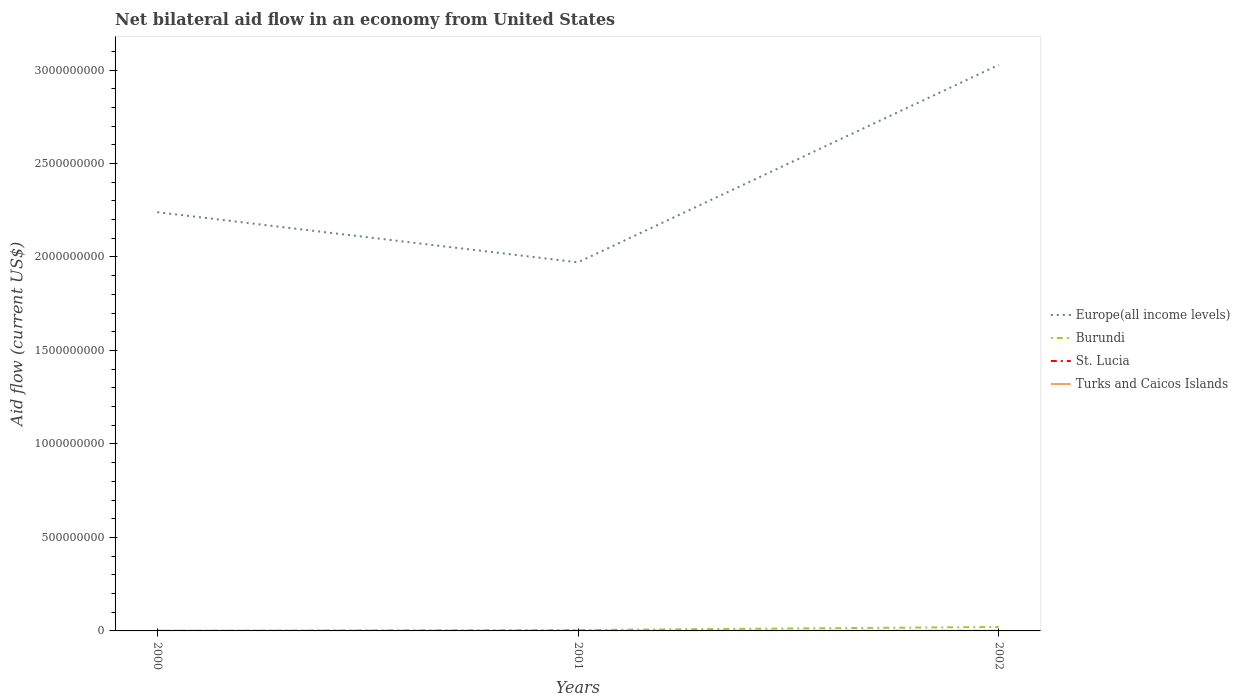Is the number of lines equal to the number of legend labels?
Provide a short and direct response. Yes. Across all years, what is the maximum net bilateral aid flow in Burundi?
Your answer should be very brief. 9.60e+05. In which year was the net bilateral aid flow in St. Lucia maximum?
Ensure brevity in your answer.  2001. What is the difference between the highest and the second highest net bilateral aid flow in Burundi?
Keep it short and to the point. 2.02e+07. Is the net bilateral aid flow in Turks and Caicos Islands strictly greater than the net bilateral aid flow in Burundi over the years?
Your response must be concise. Yes. How many lines are there?
Ensure brevity in your answer.  4. What is the difference between two consecutive major ticks on the Y-axis?
Provide a short and direct response. 5.00e+08. Does the graph contain any zero values?
Ensure brevity in your answer.  No. Does the graph contain grids?
Ensure brevity in your answer.  No. Where does the legend appear in the graph?
Provide a succinct answer. Center right. How many legend labels are there?
Offer a terse response. 4. What is the title of the graph?
Make the answer very short. Net bilateral aid flow in an economy from United States. What is the Aid flow (current US$) of Europe(all income levels) in 2000?
Your answer should be compact. 2.24e+09. What is the Aid flow (current US$) in Burundi in 2000?
Offer a terse response. 9.60e+05. What is the Aid flow (current US$) in St. Lucia in 2000?
Your response must be concise. 2.90e+05. What is the Aid flow (current US$) in Turks and Caicos Islands in 2000?
Ensure brevity in your answer.  10000. What is the Aid flow (current US$) in Europe(all income levels) in 2001?
Give a very brief answer. 1.97e+09. What is the Aid flow (current US$) of Burundi in 2001?
Your answer should be very brief. 4.85e+06. What is the Aid flow (current US$) of Turks and Caicos Islands in 2001?
Provide a succinct answer. 4.00e+04. What is the Aid flow (current US$) of Europe(all income levels) in 2002?
Your answer should be compact. 3.03e+09. What is the Aid flow (current US$) in Burundi in 2002?
Offer a very short reply. 2.12e+07. What is the Aid flow (current US$) of St. Lucia in 2002?
Your answer should be compact. 2.40e+05. What is the Aid flow (current US$) of Turks and Caicos Islands in 2002?
Ensure brevity in your answer.  10000. Across all years, what is the maximum Aid flow (current US$) of Europe(all income levels)?
Provide a short and direct response. 3.03e+09. Across all years, what is the maximum Aid flow (current US$) of Burundi?
Make the answer very short. 2.12e+07. Across all years, what is the maximum Aid flow (current US$) of St. Lucia?
Your response must be concise. 2.90e+05. Across all years, what is the minimum Aid flow (current US$) in Europe(all income levels)?
Provide a succinct answer. 1.97e+09. Across all years, what is the minimum Aid flow (current US$) of Burundi?
Provide a short and direct response. 9.60e+05. Across all years, what is the minimum Aid flow (current US$) of St. Lucia?
Provide a succinct answer. 1.50e+05. What is the total Aid flow (current US$) in Europe(all income levels) in the graph?
Keep it short and to the point. 7.24e+09. What is the total Aid flow (current US$) of Burundi in the graph?
Ensure brevity in your answer.  2.70e+07. What is the total Aid flow (current US$) in St. Lucia in the graph?
Provide a succinct answer. 6.80e+05. What is the difference between the Aid flow (current US$) in Europe(all income levels) in 2000 and that in 2001?
Offer a very short reply. 2.68e+08. What is the difference between the Aid flow (current US$) of Burundi in 2000 and that in 2001?
Give a very brief answer. -3.89e+06. What is the difference between the Aid flow (current US$) in St. Lucia in 2000 and that in 2001?
Give a very brief answer. 1.40e+05. What is the difference between the Aid flow (current US$) of Turks and Caicos Islands in 2000 and that in 2001?
Keep it short and to the point. -3.00e+04. What is the difference between the Aid flow (current US$) of Europe(all income levels) in 2000 and that in 2002?
Ensure brevity in your answer.  -7.88e+08. What is the difference between the Aid flow (current US$) in Burundi in 2000 and that in 2002?
Offer a terse response. -2.02e+07. What is the difference between the Aid flow (current US$) in St. Lucia in 2000 and that in 2002?
Give a very brief answer. 5.00e+04. What is the difference between the Aid flow (current US$) of Europe(all income levels) in 2001 and that in 2002?
Your answer should be very brief. -1.06e+09. What is the difference between the Aid flow (current US$) in Burundi in 2001 and that in 2002?
Offer a terse response. -1.63e+07. What is the difference between the Aid flow (current US$) of Turks and Caicos Islands in 2001 and that in 2002?
Offer a very short reply. 3.00e+04. What is the difference between the Aid flow (current US$) of Europe(all income levels) in 2000 and the Aid flow (current US$) of Burundi in 2001?
Offer a terse response. 2.23e+09. What is the difference between the Aid flow (current US$) of Europe(all income levels) in 2000 and the Aid flow (current US$) of St. Lucia in 2001?
Your response must be concise. 2.24e+09. What is the difference between the Aid flow (current US$) of Europe(all income levels) in 2000 and the Aid flow (current US$) of Turks and Caicos Islands in 2001?
Offer a terse response. 2.24e+09. What is the difference between the Aid flow (current US$) in Burundi in 2000 and the Aid flow (current US$) in St. Lucia in 2001?
Ensure brevity in your answer.  8.10e+05. What is the difference between the Aid flow (current US$) of Burundi in 2000 and the Aid flow (current US$) of Turks and Caicos Islands in 2001?
Make the answer very short. 9.20e+05. What is the difference between the Aid flow (current US$) in St. Lucia in 2000 and the Aid flow (current US$) in Turks and Caicos Islands in 2001?
Give a very brief answer. 2.50e+05. What is the difference between the Aid flow (current US$) in Europe(all income levels) in 2000 and the Aid flow (current US$) in Burundi in 2002?
Provide a succinct answer. 2.22e+09. What is the difference between the Aid flow (current US$) in Europe(all income levels) in 2000 and the Aid flow (current US$) in St. Lucia in 2002?
Provide a succinct answer. 2.24e+09. What is the difference between the Aid flow (current US$) in Europe(all income levels) in 2000 and the Aid flow (current US$) in Turks and Caicos Islands in 2002?
Ensure brevity in your answer.  2.24e+09. What is the difference between the Aid flow (current US$) of Burundi in 2000 and the Aid flow (current US$) of St. Lucia in 2002?
Provide a succinct answer. 7.20e+05. What is the difference between the Aid flow (current US$) in Burundi in 2000 and the Aid flow (current US$) in Turks and Caicos Islands in 2002?
Give a very brief answer. 9.50e+05. What is the difference between the Aid flow (current US$) of Europe(all income levels) in 2001 and the Aid flow (current US$) of Burundi in 2002?
Offer a terse response. 1.95e+09. What is the difference between the Aid flow (current US$) of Europe(all income levels) in 2001 and the Aid flow (current US$) of St. Lucia in 2002?
Provide a succinct answer. 1.97e+09. What is the difference between the Aid flow (current US$) in Europe(all income levels) in 2001 and the Aid flow (current US$) in Turks and Caicos Islands in 2002?
Give a very brief answer. 1.97e+09. What is the difference between the Aid flow (current US$) of Burundi in 2001 and the Aid flow (current US$) of St. Lucia in 2002?
Keep it short and to the point. 4.61e+06. What is the difference between the Aid flow (current US$) in Burundi in 2001 and the Aid flow (current US$) in Turks and Caicos Islands in 2002?
Provide a succinct answer. 4.84e+06. What is the average Aid flow (current US$) in Europe(all income levels) per year?
Your response must be concise. 2.41e+09. What is the average Aid flow (current US$) in Burundi per year?
Your answer should be compact. 8.99e+06. What is the average Aid flow (current US$) of St. Lucia per year?
Your response must be concise. 2.27e+05. In the year 2000, what is the difference between the Aid flow (current US$) in Europe(all income levels) and Aid flow (current US$) in Burundi?
Ensure brevity in your answer.  2.24e+09. In the year 2000, what is the difference between the Aid flow (current US$) of Europe(all income levels) and Aid flow (current US$) of St. Lucia?
Provide a short and direct response. 2.24e+09. In the year 2000, what is the difference between the Aid flow (current US$) of Europe(all income levels) and Aid flow (current US$) of Turks and Caicos Islands?
Offer a very short reply. 2.24e+09. In the year 2000, what is the difference between the Aid flow (current US$) of Burundi and Aid flow (current US$) of St. Lucia?
Your answer should be very brief. 6.70e+05. In the year 2000, what is the difference between the Aid flow (current US$) of Burundi and Aid flow (current US$) of Turks and Caicos Islands?
Make the answer very short. 9.50e+05. In the year 2000, what is the difference between the Aid flow (current US$) of St. Lucia and Aid flow (current US$) of Turks and Caicos Islands?
Make the answer very short. 2.80e+05. In the year 2001, what is the difference between the Aid flow (current US$) in Europe(all income levels) and Aid flow (current US$) in Burundi?
Offer a terse response. 1.97e+09. In the year 2001, what is the difference between the Aid flow (current US$) in Europe(all income levels) and Aid flow (current US$) in St. Lucia?
Ensure brevity in your answer.  1.97e+09. In the year 2001, what is the difference between the Aid flow (current US$) of Europe(all income levels) and Aid flow (current US$) of Turks and Caicos Islands?
Your response must be concise. 1.97e+09. In the year 2001, what is the difference between the Aid flow (current US$) of Burundi and Aid flow (current US$) of St. Lucia?
Provide a short and direct response. 4.70e+06. In the year 2001, what is the difference between the Aid flow (current US$) in Burundi and Aid flow (current US$) in Turks and Caicos Islands?
Keep it short and to the point. 4.81e+06. In the year 2001, what is the difference between the Aid flow (current US$) of St. Lucia and Aid flow (current US$) of Turks and Caicos Islands?
Your answer should be very brief. 1.10e+05. In the year 2002, what is the difference between the Aid flow (current US$) of Europe(all income levels) and Aid flow (current US$) of Burundi?
Provide a succinct answer. 3.01e+09. In the year 2002, what is the difference between the Aid flow (current US$) in Europe(all income levels) and Aid flow (current US$) in St. Lucia?
Provide a short and direct response. 3.03e+09. In the year 2002, what is the difference between the Aid flow (current US$) in Europe(all income levels) and Aid flow (current US$) in Turks and Caicos Islands?
Make the answer very short. 3.03e+09. In the year 2002, what is the difference between the Aid flow (current US$) of Burundi and Aid flow (current US$) of St. Lucia?
Make the answer very short. 2.09e+07. In the year 2002, what is the difference between the Aid flow (current US$) of Burundi and Aid flow (current US$) of Turks and Caicos Islands?
Give a very brief answer. 2.12e+07. What is the ratio of the Aid flow (current US$) of Europe(all income levels) in 2000 to that in 2001?
Provide a succinct answer. 1.14. What is the ratio of the Aid flow (current US$) of Burundi in 2000 to that in 2001?
Offer a very short reply. 0.2. What is the ratio of the Aid flow (current US$) in St. Lucia in 2000 to that in 2001?
Ensure brevity in your answer.  1.93. What is the ratio of the Aid flow (current US$) of Turks and Caicos Islands in 2000 to that in 2001?
Keep it short and to the point. 0.25. What is the ratio of the Aid flow (current US$) of Europe(all income levels) in 2000 to that in 2002?
Your answer should be compact. 0.74. What is the ratio of the Aid flow (current US$) in Burundi in 2000 to that in 2002?
Provide a succinct answer. 0.05. What is the ratio of the Aid flow (current US$) of St. Lucia in 2000 to that in 2002?
Offer a terse response. 1.21. What is the ratio of the Aid flow (current US$) of Europe(all income levels) in 2001 to that in 2002?
Provide a short and direct response. 0.65. What is the ratio of the Aid flow (current US$) in Burundi in 2001 to that in 2002?
Offer a very short reply. 0.23. What is the ratio of the Aid flow (current US$) in Turks and Caicos Islands in 2001 to that in 2002?
Your answer should be very brief. 4. What is the difference between the highest and the second highest Aid flow (current US$) in Europe(all income levels)?
Ensure brevity in your answer.  7.88e+08. What is the difference between the highest and the second highest Aid flow (current US$) of Burundi?
Your response must be concise. 1.63e+07. What is the difference between the highest and the second highest Aid flow (current US$) of St. Lucia?
Ensure brevity in your answer.  5.00e+04. What is the difference between the highest and the second highest Aid flow (current US$) in Turks and Caicos Islands?
Make the answer very short. 3.00e+04. What is the difference between the highest and the lowest Aid flow (current US$) of Europe(all income levels)?
Make the answer very short. 1.06e+09. What is the difference between the highest and the lowest Aid flow (current US$) of Burundi?
Your answer should be compact. 2.02e+07. What is the difference between the highest and the lowest Aid flow (current US$) in Turks and Caicos Islands?
Your answer should be compact. 3.00e+04. 